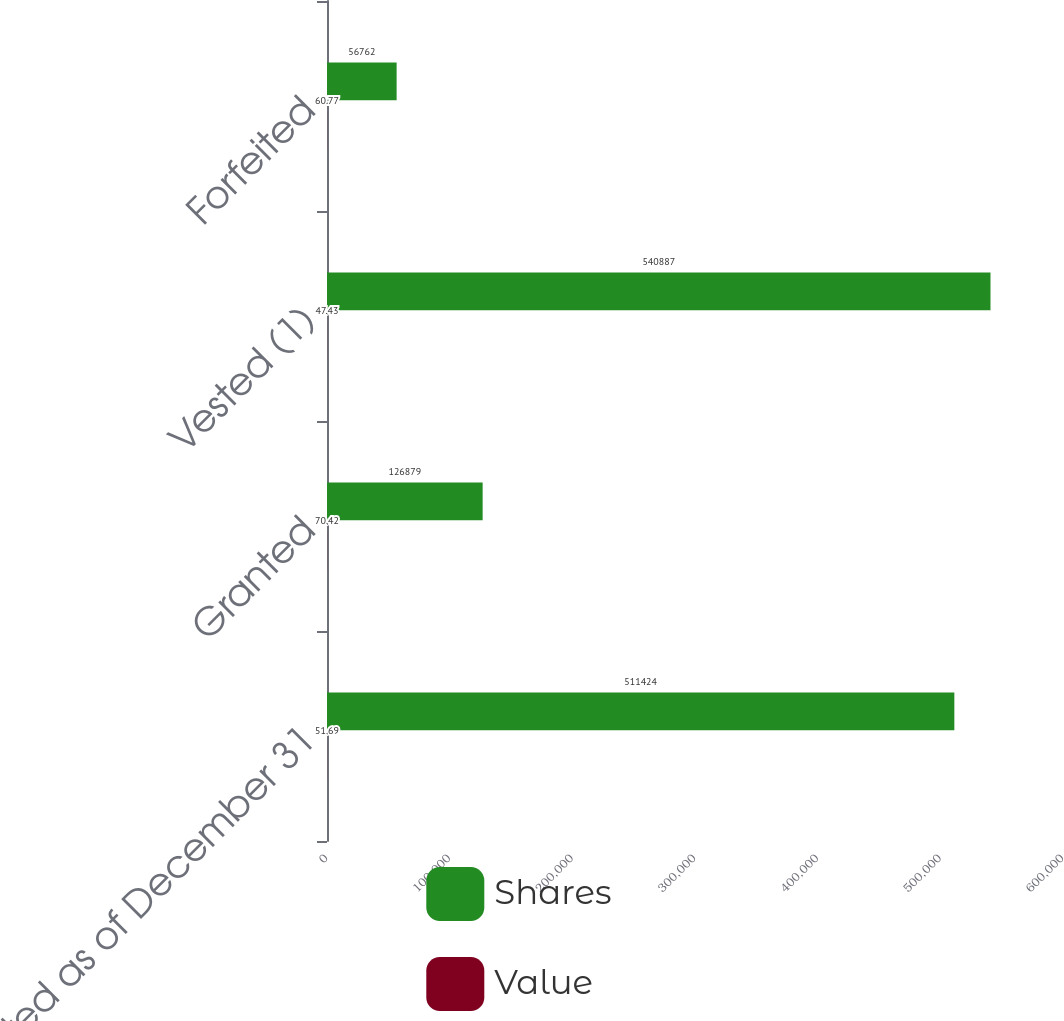Convert chart to OTSL. <chart><loc_0><loc_0><loc_500><loc_500><stacked_bar_chart><ecel><fcel>Non-vested as of December 31<fcel>Granted<fcel>Vested (1)<fcel>Forfeited<nl><fcel>Shares<fcel>511424<fcel>126879<fcel>540887<fcel>56762<nl><fcel>Value<fcel>51.69<fcel>70.42<fcel>47.43<fcel>60.77<nl></chart> 